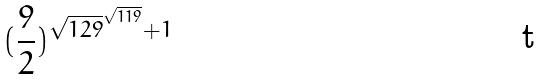Convert formula to latex. <formula><loc_0><loc_0><loc_500><loc_500>( \frac { 9 } { 2 } ) ^ { \sqrt { 1 2 9 } ^ { \sqrt { 1 1 9 } } + 1 }</formula> 